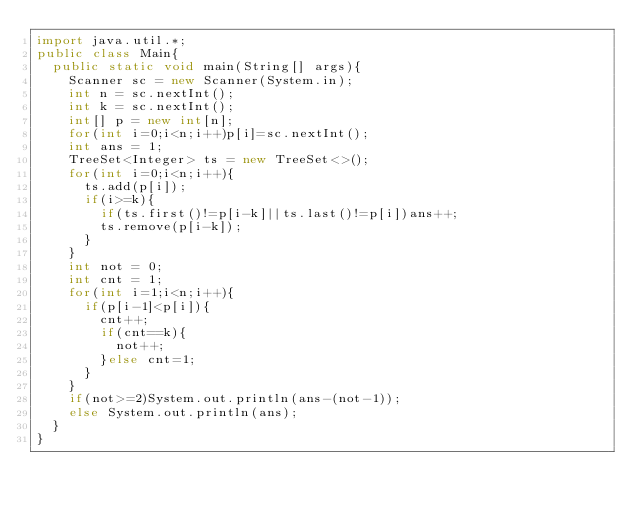<code> <loc_0><loc_0><loc_500><loc_500><_Java_>import java.util.*;
public class Main{
  public static void main(String[] args){
    Scanner sc = new Scanner(System.in);
    int n = sc.nextInt();
    int k = sc.nextInt();
    int[] p = new int[n];
    for(int i=0;i<n;i++)p[i]=sc.nextInt();
    int ans = 1;
    TreeSet<Integer> ts = new TreeSet<>();
    for(int i=0;i<n;i++){
      ts.add(p[i]);
      if(i>=k){
        if(ts.first()!=p[i-k]||ts.last()!=p[i])ans++;
        ts.remove(p[i-k]);
      }
    }
    int not = 0;
    int cnt = 1;
    for(int i=1;i<n;i++){
      if(p[i-1]<p[i]){
        cnt++;
        if(cnt==k){
          not++;
        }else cnt=1;
      }
    }
    if(not>=2)System.out.println(ans-(not-1));
    else System.out.println(ans);
  }
}</code> 